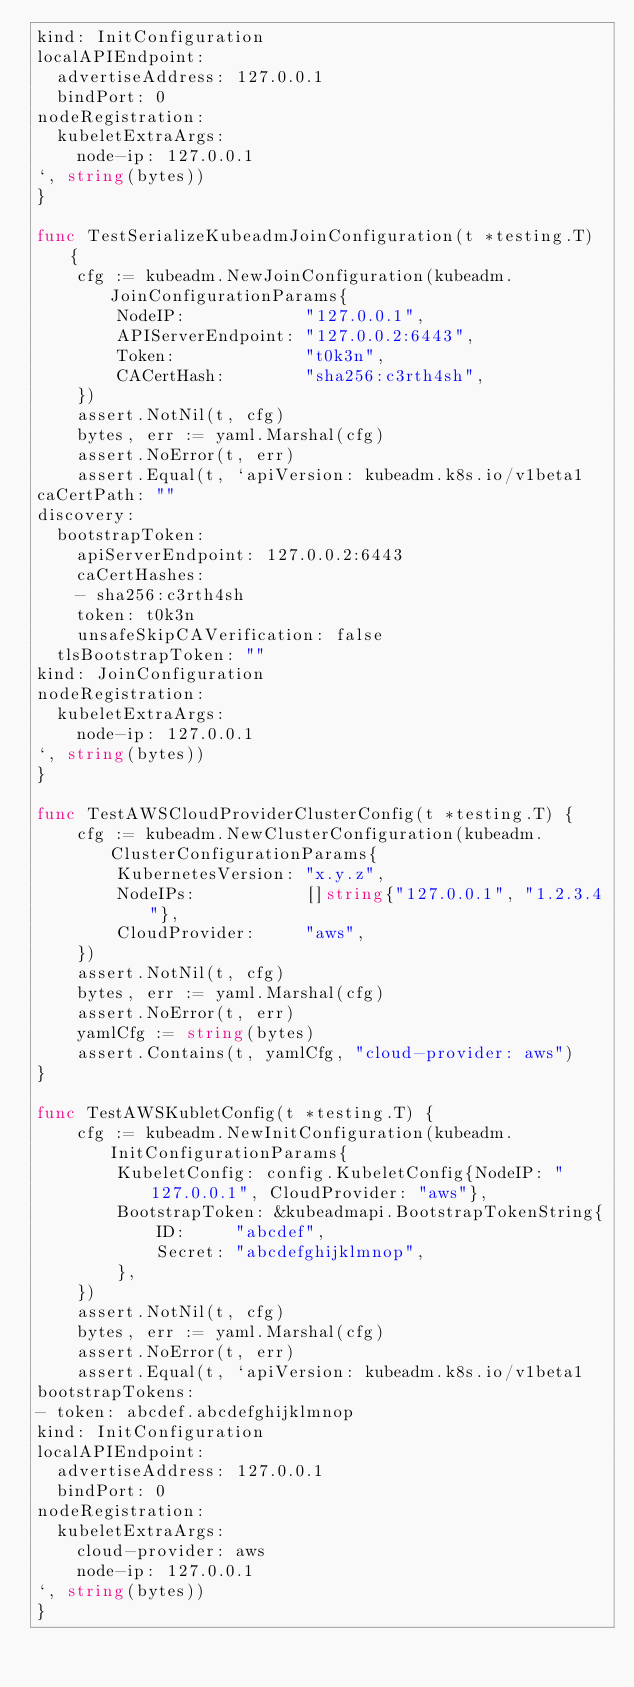<code> <loc_0><loc_0><loc_500><loc_500><_Go_>kind: InitConfiguration
localAPIEndpoint:
  advertiseAddress: 127.0.0.1
  bindPort: 0
nodeRegistration:
  kubeletExtraArgs:
    node-ip: 127.0.0.1
`, string(bytes))
}

func TestSerializeKubeadmJoinConfiguration(t *testing.T) {
	cfg := kubeadm.NewJoinConfiguration(kubeadm.JoinConfigurationParams{
		NodeIP:            "127.0.0.1",
		APIServerEndpoint: "127.0.0.2:6443",
		Token:             "t0k3n",
		CACertHash:        "sha256:c3rth4sh",
	})
	assert.NotNil(t, cfg)
	bytes, err := yaml.Marshal(cfg)
	assert.NoError(t, err)
	assert.Equal(t, `apiVersion: kubeadm.k8s.io/v1beta1
caCertPath: ""
discovery:
  bootstrapToken:
    apiServerEndpoint: 127.0.0.2:6443
    caCertHashes:
    - sha256:c3rth4sh
    token: t0k3n
    unsafeSkipCAVerification: false
  tlsBootstrapToken: ""
kind: JoinConfiguration
nodeRegistration:
  kubeletExtraArgs:
    node-ip: 127.0.0.1
`, string(bytes))
}

func TestAWSCloudProviderClusterConfig(t *testing.T) {
	cfg := kubeadm.NewClusterConfiguration(kubeadm.ClusterConfigurationParams{
		KubernetesVersion: "x.y.z",
		NodeIPs:           []string{"127.0.0.1", "1.2.3.4"},
		CloudProvider:     "aws",
	})
	assert.NotNil(t, cfg)
	bytes, err := yaml.Marshal(cfg)
	assert.NoError(t, err)
	yamlCfg := string(bytes)
	assert.Contains(t, yamlCfg, "cloud-provider: aws")
}

func TestAWSKubletConfig(t *testing.T) {
	cfg := kubeadm.NewInitConfiguration(kubeadm.InitConfigurationParams{
		KubeletConfig: config.KubeletConfig{NodeIP: "127.0.0.1", CloudProvider: "aws"},
		BootstrapToken: &kubeadmapi.BootstrapTokenString{
			ID:     "abcdef",
			Secret: "abcdefghijklmnop",
		},
	})
	assert.NotNil(t, cfg)
	bytes, err := yaml.Marshal(cfg)
	assert.NoError(t, err)
	assert.Equal(t, `apiVersion: kubeadm.k8s.io/v1beta1
bootstrapTokens:
- token: abcdef.abcdefghijklmnop
kind: InitConfiguration
localAPIEndpoint:
  advertiseAddress: 127.0.0.1
  bindPort: 0
nodeRegistration:
  kubeletExtraArgs:
    cloud-provider: aws
    node-ip: 127.0.0.1
`, string(bytes))
}
</code> 